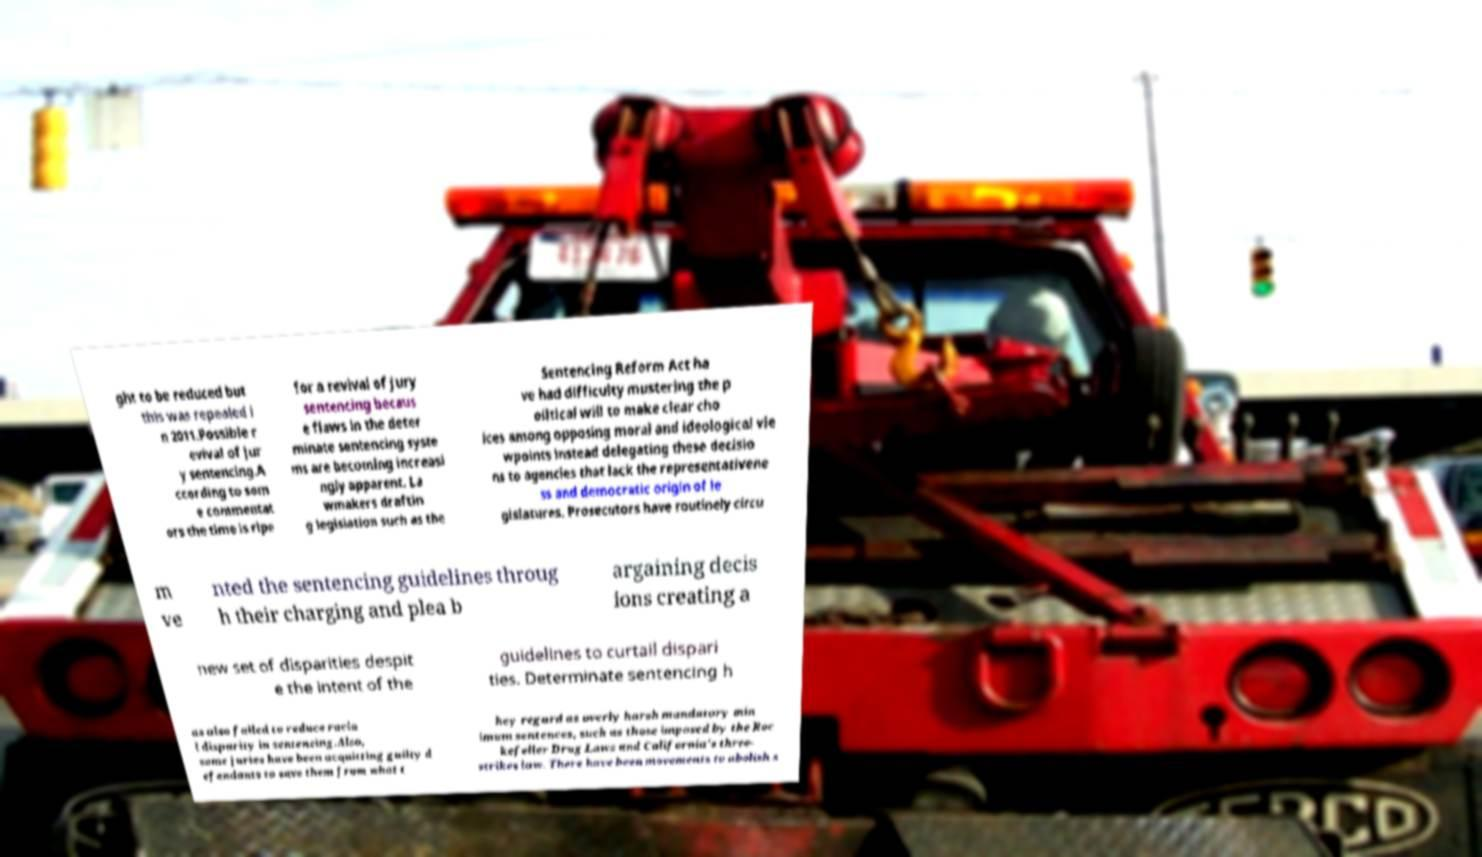For documentation purposes, I need the text within this image transcribed. Could you provide that? ght to be reduced but this was repealed i n 2011.Possible r evival of jur y sentencing.A ccording to som e commentat ors the time is ripe for a revival of jury sentencing becaus e flaws in the deter minate sentencing syste ms are becoming increasi ngly apparent. La wmakers draftin g legislation such as the Sentencing Reform Act ha ve had difficulty mustering the p olitical will to make clear cho ices among opposing moral and ideological vie wpoints instead delegating these decisio ns to agencies that lack the representativene ss and democratic origin of le gislatures. Prosecutors have routinely circu m ve nted the sentencing guidelines throug h their charging and plea b argaining decis ions creating a new set of disparities despit e the intent of the guidelines to curtail dispari ties. Determinate sentencing h as also failed to reduce racia l disparity in sentencing.Also, some juries have been acquitting guilty d efendants to save them from what t hey regard as overly harsh mandatory min imum sentences, such as those imposed by the Roc kefeller Drug Laws and California's three- strikes law. There have been movements to abolish s 